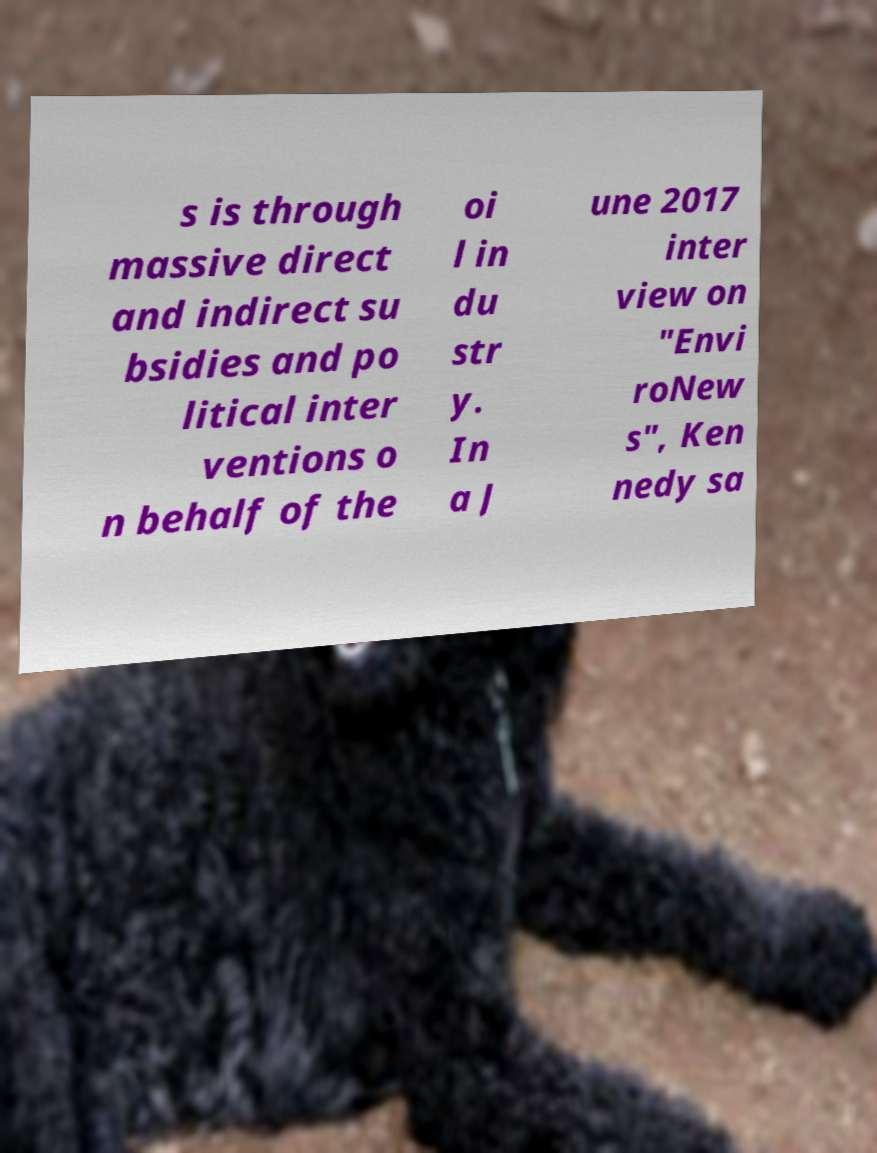Could you extract and type out the text from this image? s is through massive direct and indirect su bsidies and po litical inter ventions o n behalf of the oi l in du str y. In a J une 2017 inter view on "Envi roNew s", Ken nedy sa 